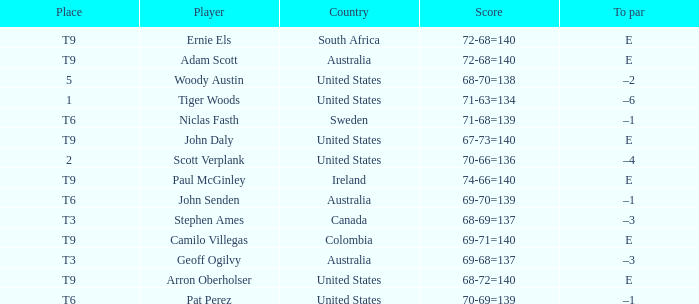What country is Adam Scott from? Australia. 